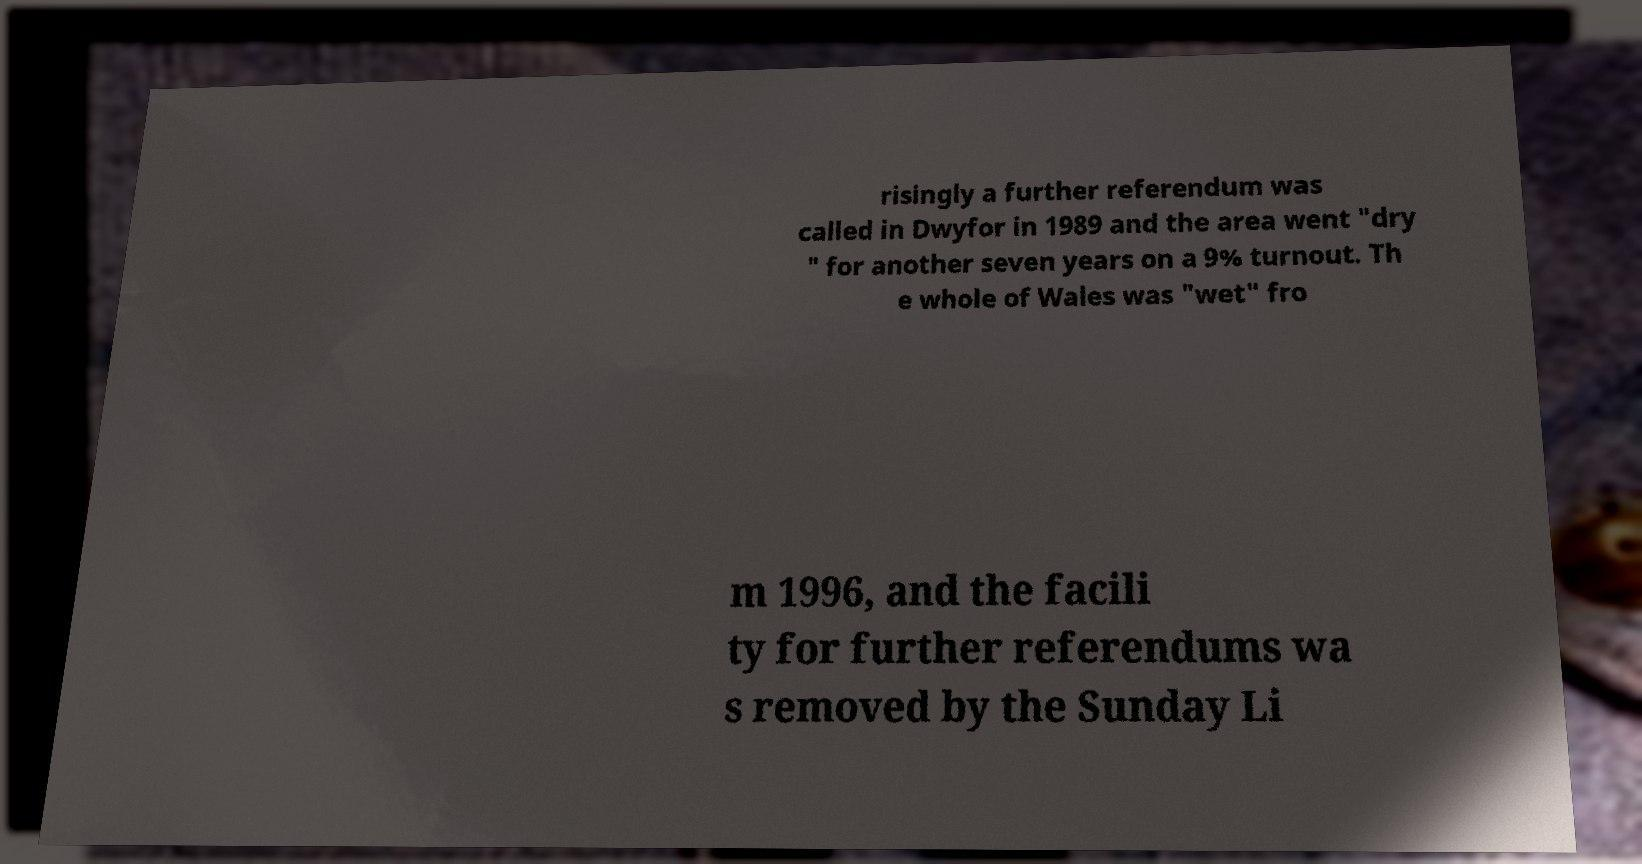I need the written content from this picture converted into text. Can you do that? risingly a further referendum was called in Dwyfor in 1989 and the area went "dry " for another seven years on a 9% turnout. Th e whole of Wales was "wet" fro m 1996, and the facili ty for further referendums wa s removed by the Sunday Li 